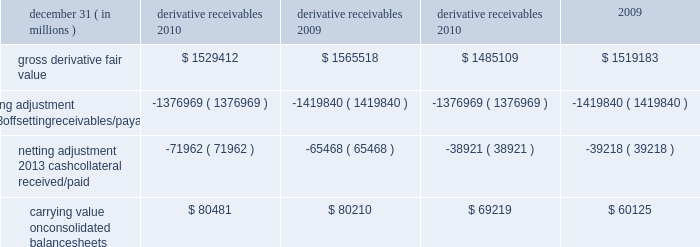Jpmorgan chase & co./2010 annual report 197 the table shows the current credit risk of derivative receivables after netting adjustments , and the current liquidity risk of derivative payables after netting adjustments , as of december 31 , 2010 and 2009. .
In addition to the collateral amounts reflected in the table above , at december 31 , 2010 and 2009 , the firm had received liquid securi- ties and other cash collateral in the amount of $ 16.5 billion and $ 15.5 billion , respectively , and had posted $ 10.9 billion and $ 11.7 billion , respectively .
The firm also receives and delivers collateral at the initiation of derivative transactions , which is available as secu- rity against potential exposure that could arise should the fair value of the transactions move in the firm 2019s or client 2019s favor , respectively .
Furthermore , the firm and its counterparties hold collateral related to contracts that have a non-daily call frequency for collateral to be posted , and collateral that the firm or a counterparty has agreed to return but has not yet settled as of the reporting date .
At december 31 , 2010 and 2009 , the firm had received $ 18.0 billion and $ 16.9 billion , respectively , and delivered $ 8.4 billion and $ 5.8 billion , respectively , of such additional collateral .
These amounts were not netted against the derivative receivables and payables in the table above , because , at an individual counterparty level , the collateral exceeded the fair value exposure at december 31 , 2010 and 2009 .
Credit derivatives credit derivatives are financial instruments whose value is derived from the credit risk associated with the debt of a third-party issuer ( the reference entity ) and which allow one party ( the protection purchaser ) to transfer that risk to another party ( the protection seller ) .
Credit derivatives expose the protection purchaser to the creditworthiness of the protection seller , as the protection seller is required to make payments under the contract when the reference entity experiences a credit event , such as a bankruptcy , a failure to pay its obligation or a restructuring .
The seller of credit protection receives a premium for providing protection but has the risk that the underlying instrument referenced in the contract will be subject to a credit event .
The firm is both a purchaser and seller of protection in the credit derivatives market and uses these derivatives for two primary purposes .
First , in its capacity as a market-maker in the dealer/client business , the firm actively risk manages a portfolio of credit derivatives by purchasing and selling credit protection , pre- dominantly on corporate debt obligations , to meet the needs of customers .
As a seller of protection , the firm 2019s exposure to a given reference entity may be offset partially , or entirely , with a contract to purchase protection from another counterparty on the same or similar reference entity .
Second , the firm uses credit derivatives to mitigate credit risk associated with its overall derivative receivables and traditional commercial credit lending exposures ( loans and unfunded commitments ) as well as to manage its exposure to residential and commercial mortgages .
See note 3 on pages 170 2013 187 of this annual report for further information on the firm 2019s mortgage-related exposures .
In accomplishing the above , the firm uses different types of credit derivatives .
Following is a summary of various types of credit derivatives .
Credit default swaps credit derivatives may reference the credit of either a single refer- ence entity ( 201csingle-name 201d ) or a broad-based index .
The firm purchases and sells protection on both single- name and index- reference obligations .
Single-name cds and index cds contracts are otc derivative contracts .
Single-name cds are used to manage the default risk of a single reference entity , while index cds con- tracts are used to manage the credit risk associated with the broader credit markets or credit market segments .
Like the s&p 500 and other market indices , a cds index comprises a portfolio of cds across many reference entities .
New series of cds indices are periodically established with a new underlying portfolio of reference entities to reflect changes in the credit markets .
If one of the refer- ence entities in the index experiences a credit event , then the reference entity that defaulted is removed from the index .
Cds can also be referenced against specific portfolios of reference names or against customized exposure levels based on specific client de- mands : for example , to provide protection against the first $ 1 million of realized credit losses in a $ 10 million portfolio of expo- sure .
Such structures are commonly known as tranche cds .
For both single-name cds contracts and index cds contracts , upon the occurrence of a credit event , under the terms of a cds contract neither party to the cds contract has recourse to the reference entity .
The protection purchaser has recourse to the protection seller for the difference between the face value of the cds contract and the fair value of the reference obligation at the time of settling the credit derivative contract , also known as the recovery value .
The protection purchaser does not need to hold the debt instrument of the underlying reference entity in order to receive amounts due under the cds contract when a credit event occurs .
Credit-related notes a credit-related note is a funded credit derivative where the issuer of the credit-related note purchases from the note investor credit protec- tion on a referenced entity .
Under the contract , the investor pays the issuer the par value of the note at the inception of the transaction , and in return , the issuer pays periodic payments to the investor , based on the credit risk of the referenced entity .
The issuer also repays the investor the par value of the note at maturity unless the reference entity experiences a specified credit event .
If a credit event .
For 2010 , how much in billions would the credit risk balance be reduced if the table considered all other collateral? 
Computations: (16.5 + 18.0)
Answer: 34.5. 